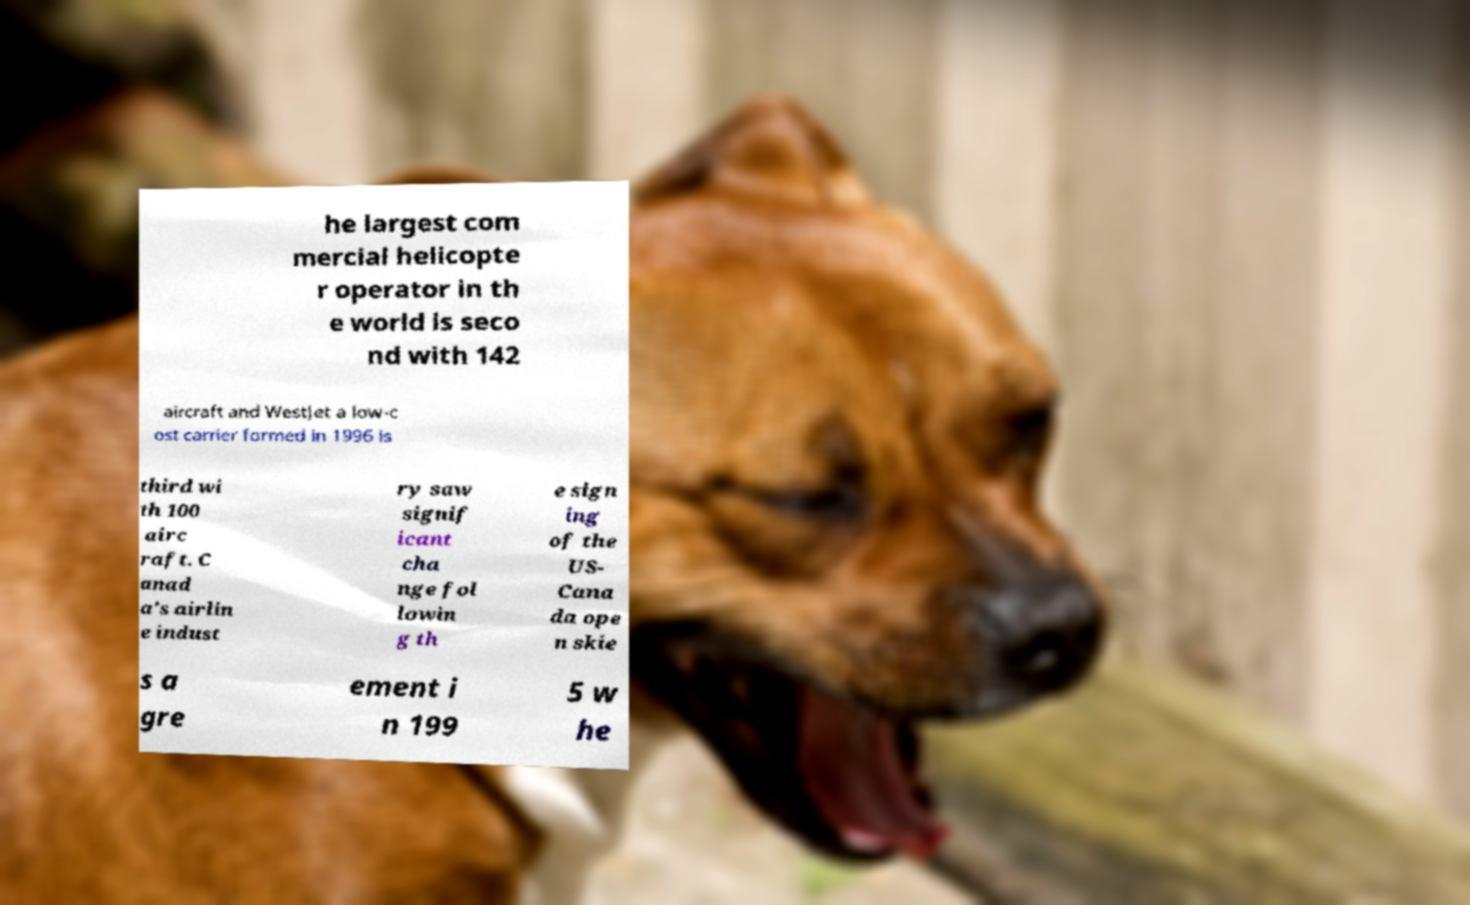Could you extract and type out the text from this image? he largest com mercial helicopte r operator in th e world is seco nd with 142 aircraft and WestJet a low-c ost carrier formed in 1996 is third wi th 100 airc raft. C anad a's airlin e indust ry saw signif icant cha nge fol lowin g th e sign ing of the US- Cana da ope n skie s a gre ement i n 199 5 w he 